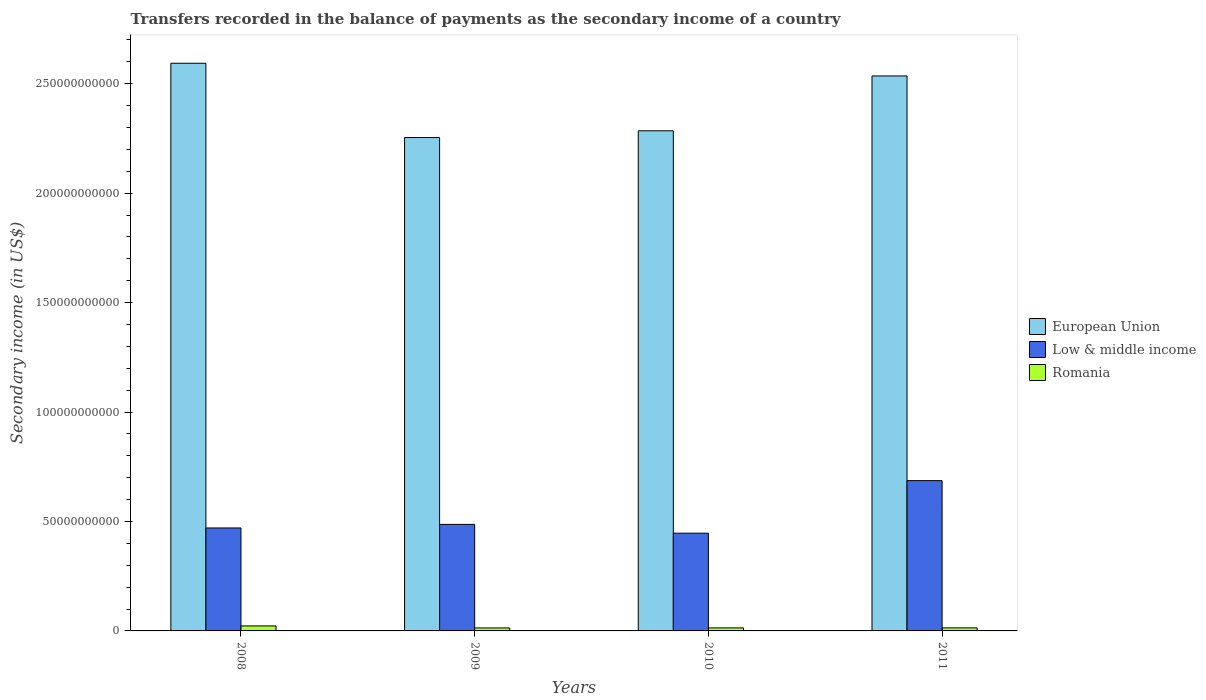How many different coloured bars are there?
Offer a very short reply. 3. Are the number of bars per tick equal to the number of legend labels?
Provide a short and direct response. Yes. How many bars are there on the 3rd tick from the left?
Your response must be concise. 3. How many bars are there on the 2nd tick from the right?
Offer a terse response. 3. What is the label of the 3rd group of bars from the left?
Ensure brevity in your answer.  2010. What is the secondary income of in Low & middle income in 2010?
Give a very brief answer. 4.46e+1. Across all years, what is the maximum secondary income of in European Union?
Make the answer very short. 2.59e+11. Across all years, what is the minimum secondary income of in Romania?
Your answer should be compact. 1.36e+09. In which year was the secondary income of in Romania minimum?
Offer a terse response. 2009. What is the total secondary income of in European Union in the graph?
Your response must be concise. 9.67e+11. What is the difference between the secondary income of in Romania in 2009 and that in 2011?
Give a very brief answer. -4.00e+07. What is the difference between the secondary income of in Romania in 2011 and the secondary income of in Low & middle income in 2009?
Your answer should be compact. -4.73e+1. What is the average secondary income of in Romania per year?
Offer a terse response. 1.61e+09. In the year 2011, what is the difference between the secondary income of in European Union and secondary income of in Romania?
Make the answer very short. 2.52e+11. In how many years, is the secondary income of in Romania greater than 200000000000 US$?
Give a very brief answer. 0. What is the ratio of the secondary income of in Low & middle income in 2008 to that in 2010?
Keep it short and to the point. 1.05. Is the secondary income of in European Union in 2008 less than that in 2010?
Your response must be concise. No. What is the difference between the highest and the second highest secondary income of in European Union?
Ensure brevity in your answer.  5.79e+09. What is the difference between the highest and the lowest secondary income of in European Union?
Keep it short and to the point. 3.39e+1. In how many years, is the secondary income of in Low & middle income greater than the average secondary income of in Low & middle income taken over all years?
Offer a terse response. 1. Is the sum of the secondary income of in Low & middle income in 2010 and 2011 greater than the maximum secondary income of in European Union across all years?
Offer a terse response. No. What does the 2nd bar from the left in 2010 represents?
Your answer should be compact. Low & middle income. Are all the bars in the graph horizontal?
Your answer should be compact. No. What is the difference between two consecutive major ticks on the Y-axis?
Keep it short and to the point. 5.00e+1. Are the values on the major ticks of Y-axis written in scientific E-notation?
Your answer should be compact. No. What is the title of the graph?
Ensure brevity in your answer.  Transfers recorded in the balance of payments as the secondary income of a country. Does "Tunisia" appear as one of the legend labels in the graph?
Provide a short and direct response. No. What is the label or title of the X-axis?
Keep it short and to the point. Years. What is the label or title of the Y-axis?
Give a very brief answer. Secondary income (in US$). What is the Secondary income (in US$) of European Union in 2008?
Your response must be concise. 2.59e+11. What is the Secondary income (in US$) in Low & middle income in 2008?
Give a very brief answer. 4.70e+1. What is the Secondary income (in US$) of Romania in 2008?
Your answer should be compact. 2.28e+09. What is the Secondary income (in US$) of European Union in 2009?
Your answer should be very brief. 2.25e+11. What is the Secondary income (in US$) of Low & middle income in 2009?
Your answer should be very brief. 4.87e+1. What is the Secondary income (in US$) of Romania in 2009?
Offer a terse response. 1.36e+09. What is the Secondary income (in US$) of European Union in 2010?
Your answer should be compact. 2.28e+11. What is the Secondary income (in US$) of Low & middle income in 2010?
Give a very brief answer. 4.46e+1. What is the Secondary income (in US$) of Romania in 2010?
Give a very brief answer. 1.39e+09. What is the Secondary income (in US$) in European Union in 2011?
Give a very brief answer. 2.54e+11. What is the Secondary income (in US$) in Low & middle income in 2011?
Give a very brief answer. 6.87e+1. What is the Secondary income (in US$) of Romania in 2011?
Keep it short and to the point. 1.40e+09. Across all years, what is the maximum Secondary income (in US$) of European Union?
Provide a succinct answer. 2.59e+11. Across all years, what is the maximum Secondary income (in US$) in Low & middle income?
Give a very brief answer. 6.87e+1. Across all years, what is the maximum Secondary income (in US$) of Romania?
Ensure brevity in your answer.  2.28e+09. Across all years, what is the minimum Secondary income (in US$) of European Union?
Make the answer very short. 2.25e+11. Across all years, what is the minimum Secondary income (in US$) in Low & middle income?
Offer a very short reply. 4.46e+1. Across all years, what is the minimum Secondary income (in US$) of Romania?
Keep it short and to the point. 1.36e+09. What is the total Secondary income (in US$) of European Union in the graph?
Offer a terse response. 9.67e+11. What is the total Secondary income (in US$) in Low & middle income in the graph?
Your answer should be compact. 2.09e+11. What is the total Secondary income (in US$) in Romania in the graph?
Provide a short and direct response. 6.42e+09. What is the difference between the Secondary income (in US$) of European Union in 2008 and that in 2009?
Your answer should be compact. 3.39e+1. What is the difference between the Secondary income (in US$) of Low & middle income in 2008 and that in 2009?
Give a very brief answer. -1.63e+09. What is the difference between the Secondary income (in US$) in Romania in 2008 and that in 2009?
Ensure brevity in your answer.  9.26e+08. What is the difference between the Secondary income (in US$) in European Union in 2008 and that in 2010?
Make the answer very short. 3.09e+1. What is the difference between the Secondary income (in US$) in Low & middle income in 2008 and that in 2010?
Ensure brevity in your answer.  2.38e+09. What is the difference between the Secondary income (in US$) of Romania in 2008 and that in 2010?
Give a very brief answer. 8.97e+08. What is the difference between the Secondary income (in US$) in European Union in 2008 and that in 2011?
Keep it short and to the point. 5.79e+09. What is the difference between the Secondary income (in US$) in Low & middle income in 2008 and that in 2011?
Ensure brevity in your answer.  -2.16e+1. What is the difference between the Secondary income (in US$) of Romania in 2008 and that in 2011?
Provide a short and direct response. 8.86e+08. What is the difference between the Secondary income (in US$) in European Union in 2009 and that in 2010?
Ensure brevity in your answer.  -3.08e+09. What is the difference between the Secondary income (in US$) in Low & middle income in 2009 and that in 2010?
Your answer should be compact. 4.01e+09. What is the difference between the Secondary income (in US$) in Romania in 2009 and that in 2010?
Your answer should be very brief. -2.90e+07. What is the difference between the Secondary income (in US$) in European Union in 2009 and that in 2011?
Offer a terse response. -2.81e+1. What is the difference between the Secondary income (in US$) of Low & middle income in 2009 and that in 2011?
Ensure brevity in your answer.  -2.00e+1. What is the difference between the Secondary income (in US$) of Romania in 2009 and that in 2011?
Make the answer very short. -4.00e+07. What is the difference between the Secondary income (in US$) of European Union in 2010 and that in 2011?
Provide a short and direct response. -2.51e+1. What is the difference between the Secondary income (in US$) in Low & middle income in 2010 and that in 2011?
Your response must be concise. -2.40e+1. What is the difference between the Secondary income (in US$) in Romania in 2010 and that in 2011?
Keep it short and to the point. -1.10e+07. What is the difference between the Secondary income (in US$) of European Union in 2008 and the Secondary income (in US$) of Low & middle income in 2009?
Your answer should be very brief. 2.11e+11. What is the difference between the Secondary income (in US$) in European Union in 2008 and the Secondary income (in US$) in Romania in 2009?
Keep it short and to the point. 2.58e+11. What is the difference between the Secondary income (in US$) in Low & middle income in 2008 and the Secondary income (in US$) in Romania in 2009?
Offer a terse response. 4.57e+1. What is the difference between the Secondary income (in US$) of European Union in 2008 and the Secondary income (in US$) of Low & middle income in 2010?
Offer a very short reply. 2.15e+11. What is the difference between the Secondary income (in US$) of European Union in 2008 and the Secondary income (in US$) of Romania in 2010?
Keep it short and to the point. 2.58e+11. What is the difference between the Secondary income (in US$) in Low & middle income in 2008 and the Secondary income (in US$) in Romania in 2010?
Ensure brevity in your answer.  4.56e+1. What is the difference between the Secondary income (in US$) in European Union in 2008 and the Secondary income (in US$) in Low & middle income in 2011?
Give a very brief answer. 1.91e+11. What is the difference between the Secondary income (in US$) in European Union in 2008 and the Secondary income (in US$) in Romania in 2011?
Make the answer very short. 2.58e+11. What is the difference between the Secondary income (in US$) of Low & middle income in 2008 and the Secondary income (in US$) of Romania in 2011?
Your response must be concise. 4.56e+1. What is the difference between the Secondary income (in US$) in European Union in 2009 and the Secondary income (in US$) in Low & middle income in 2010?
Provide a short and direct response. 1.81e+11. What is the difference between the Secondary income (in US$) of European Union in 2009 and the Secondary income (in US$) of Romania in 2010?
Ensure brevity in your answer.  2.24e+11. What is the difference between the Secondary income (in US$) of Low & middle income in 2009 and the Secondary income (in US$) of Romania in 2010?
Make the answer very short. 4.73e+1. What is the difference between the Secondary income (in US$) in European Union in 2009 and the Secondary income (in US$) in Low & middle income in 2011?
Your response must be concise. 1.57e+11. What is the difference between the Secondary income (in US$) in European Union in 2009 and the Secondary income (in US$) in Romania in 2011?
Keep it short and to the point. 2.24e+11. What is the difference between the Secondary income (in US$) in Low & middle income in 2009 and the Secondary income (in US$) in Romania in 2011?
Provide a short and direct response. 4.73e+1. What is the difference between the Secondary income (in US$) of European Union in 2010 and the Secondary income (in US$) of Low & middle income in 2011?
Give a very brief answer. 1.60e+11. What is the difference between the Secondary income (in US$) in European Union in 2010 and the Secondary income (in US$) in Romania in 2011?
Offer a very short reply. 2.27e+11. What is the difference between the Secondary income (in US$) of Low & middle income in 2010 and the Secondary income (in US$) of Romania in 2011?
Offer a terse response. 4.33e+1. What is the average Secondary income (in US$) in European Union per year?
Provide a short and direct response. 2.42e+11. What is the average Secondary income (in US$) in Low & middle income per year?
Give a very brief answer. 5.22e+1. What is the average Secondary income (in US$) of Romania per year?
Your response must be concise. 1.61e+09. In the year 2008, what is the difference between the Secondary income (in US$) of European Union and Secondary income (in US$) of Low & middle income?
Your response must be concise. 2.12e+11. In the year 2008, what is the difference between the Secondary income (in US$) in European Union and Secondary income (in US$) in Romania?
Make the answer very short. 2.57e+11. In the year 2008, what is the difference between the Secondary income (in US$) of Low & middle income and Secondary income (in US$) of Romania?
Make the answer very short. 4.47e+1. In the year 2009, what is the difference between the Secondary income (in US$) of European Union and Secondary income (in US$) of Low & middle income?
Offer a terse response. 1.77e+11. In the year 2009, what is the difference between the Secondary income (in US$) in European Union and Secondary income (in US$) in Romania?
Provide a short and direct response. 2.24e+11. In the year 2009, what is the difference between the Secondary income (in US$) of Low & middle income and Secondary income (in US$) of Romania?
Give a very brief answer. 4.73e+1. In the year 2010, what is the difference between the Secondary income (in US$) in European Union and Secondary income (in US$) in Low & middle income?
Offer a very short reply. 1.84e+11. In the year 2010, what is the difference between the Secondary income (in US$) of European Union and Secondary income (in US$) of Romania?
Your answer should be very brief. 2.27e+11. In the year 2010, what is the difference between the Secondary income (in US$) in Low & middle income and Secondary income (in US$) in Romania?
Your response must be concise. 4.33e+1. In the year 2011, what is the difference between the Secondary income (in US$) in European Union and Secondary income (in US$) in Low & middle income?
Offer a terse response. 1.85e+11. In the year 2011, what is the difference between the Secondary income (in US$) of European Union and Secondary income (in US$) of Romania?
Your answer should be very brief. 2.52e+11. In the year 2011, what is the difference between the Secondary income (in US$) of Low & middle income and Secondary income (in US$) of Romania?
Offer a terse response. 6.73e+1. What is the ratio of the Secondary income (in US$) of European Union in 2008 to that in 2009?
Keep it short and to the point. 1.15. What is the ratio of the Secondary income (in US$) in Low & middle income in 2008 to that in 2009?
Provide a succinct answer. 0.97. What is the ratio of the Secondary income (in US$) of Romania in 2008 to that in 2009?
Keep it short and to the point. 1.68. What is the ratio of the Secondary income (in US$) of European Union in 2008 to that in 2010?
Ensure brevity in your answer.  1.14. What is the ratio of the Secondary income (in US$) of Low & middle income in 2008 to that in 2010?
Offer a terse response. 1.05. What is the ratio of the Secondary income (in US$) of Romania in 2008 to that in 2010?
Your answer should be compact. 1.65. What is the ratio of the Secondary income (in US$) of European Union in 2008 to that in 2011?
Your answer should be compact. 1.02. What is the ratio of the Secondary income (in US$) in Low & middle income in 2008 to that in 2011?
Offer a very short reply. 0.69. What is the ratio of the Secondary income (in US$) of Romania in 2008 to that in 2011?
Offer a terse response. 1.63. What is the ratio of the Secondary income (in US$) in European Union in 2009 to that in 2010?
Ensure brevity in your answer.  0.99. What is the ratio of the Secondary income (in US$) in Low & middle income in 2009 to that in 2010?
Your answer should be compact. 1.09. What is the ratio of the Secondary income (in US$) in Romania in 2009 to that in 2010?
Your response must be concise. 0.98. What is the ratio of the Secondary income (in US$) in European Union in 2009 to that in 2011?
Your response must be concise. 0.89. What is the ratio of the Secondary income (in US$) of Low & middle income in 2009 to that in 2011?
Keep it short and to the point. 0.71. What is the ratio of the Secondary income (in US$) of Romania in 2009 to that in 2011?
Provide a short and direct response. 0.97. What is the ratio of the Secondary income (in US$) in European Union in 2010 to that in 2011?
Make the answer very short. 0.9. What is the ratio of the Secondary income (in US$) in Low & middle income in 2010 to that in 2011?
Your answer should be very brief. 0.65. What is the ratio of the Secondary income (in US$) in Romania in 2010 to that in 2011?
Ensure brevity in your answer.  0.99. What is the difference between the highest and the second highest Secondary income (in US$) of European Union?
Your answer should be compact. 5.79e+09. What is the difference between the highest and the second highest Secondary income (in US$) in Low & middle income?
Keep it short and to the point. 2.00e+1. What is the difference between the highest and the second highest Secondary income (in US$) in Romania?
Give a very brief answer. 8.86e+08. What is the difference between the highest and the lowest Secondary income (in US$) of European Union?
Your response must be concise. 3.39e+1. What is the difference between the highest and the lowest Secondary income (in US$) of Low & middle income?
Give a very brief answer. 2.40e+1. What is the difference between the highest and the lowest Secondary income (in US$) in Romania?
Your answer should be very brief. 9.26e+08. 